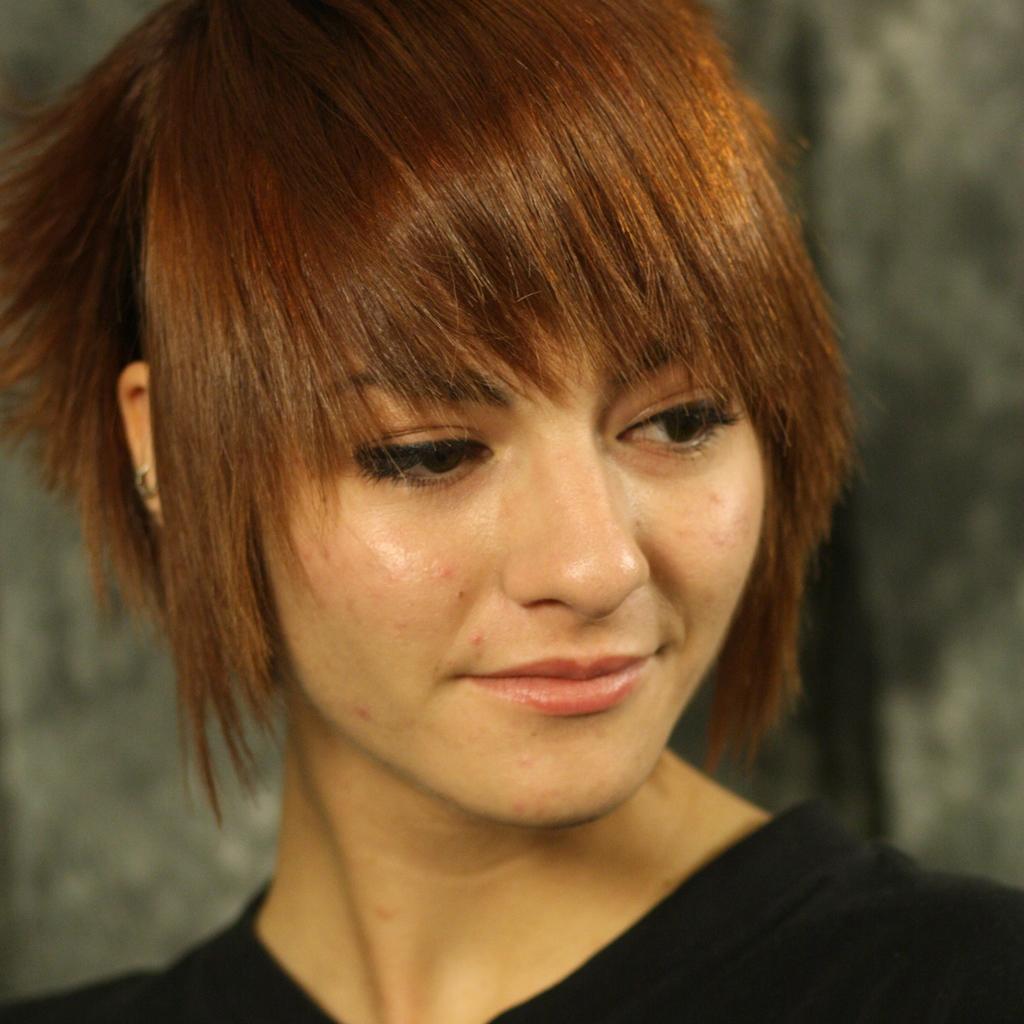In one or two sentences, can you explain what this image depicts? Here we can see a woman and there is a blur background. 